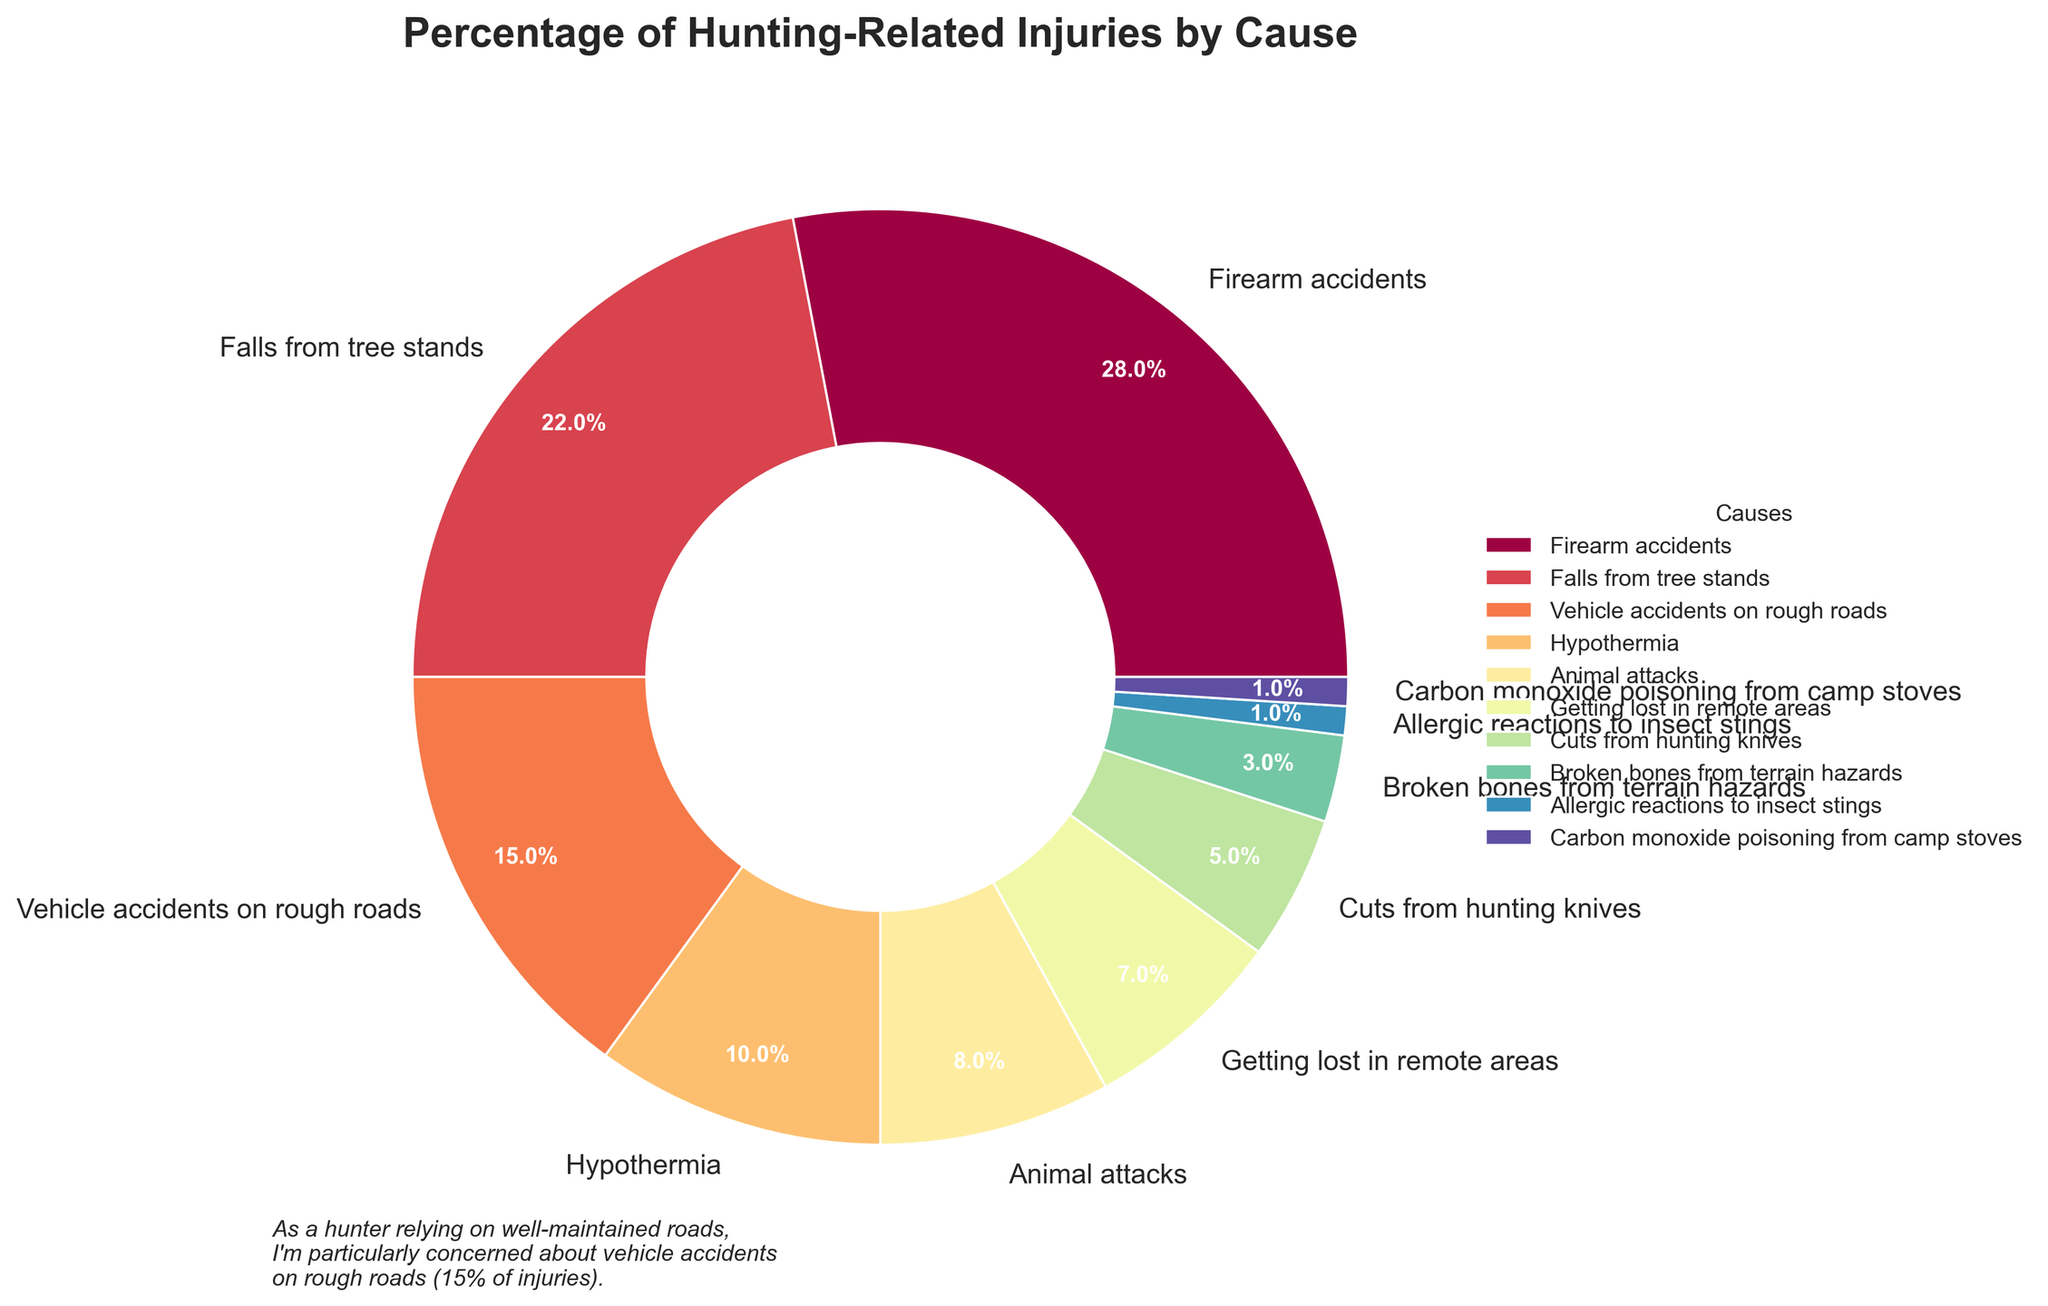What is the most common cause of hunting-related injuries? The largest wedge in the pie chart represents the most common cause. "Firearm accidents" occupy the largest segment at 28%.
Answer: Firearm accidents Which two causes combined account for 30% of hunting-related injuries? By examining the percentages, "Hypothermia" at 10% and "Animal attacks" at 8% combined are closest to 30%. However, falls from tree stands at 22% and cuts from hunting knives at 5% combined give exactly 27% and are the closest to 30%.
Answer: Falls from tree stands and cuts from hunting knives How much higher is the percentage of falls from tree stands compared to cuts from hunting knives? Identify the percentages for both causes. Falls from tree stands account for 22%, and cuts from hunting knives for 5%. The difference is 22% - 5%.
Answer: 17% What percentage of hunting-related injuries are due to factors other than firearm accidents, falls from tree stands, and vehicle accidents on rough roads? Subtract the three given percentages from 100%. Firearm accidents: 28%, falls from tree stands: 22%, vehicle accidents on rough roads: 15%. 100% - (28% + 22% + 15%) = 35%.
Answer: 35% Which cause of injuries is tied for the lowest percentage? Identify the smallest segments in the chart. Both "Allergic reactions to insect stings" and "Carbon monoxide poisoning from camp stoves" are 1%.
Answer: Allergic reactions to insect stings and Carbon monoxide poisoning from camp stoves What percentage of injuries are due to causes related to harsh weather conditions and the wilderness? Add the percentages for hypothermia and getting lost in remote areas, which are 10% and 7%, respectively. 10% + 7% = 17%.
Answer: 17% How does the percentage of injuries caused by animal attacks compare to those caused by getting lost in remote areas? The percentage for animal attacks is 8%, while getting lost accounts for 7%. Therefore, animal attacks are higher by 1%.
Answer: Animal attacks are 1% higher Which causes of injuries have percentages below 10%? Identify the values below 10% from the segments. The relevant causes are animal attacks (8%), getting lost in remote areas (7%), cuts from hunting knives (5%), broken bones from terrain hazards (3%), allergic reactions to insect stings (1%), and carbon monoxide poisoning from camp stoves (1%).
Answer: Animal attacks, Getting lost in remote areas, Cuts from hunting knives, Broken bones from terrain hazards, Allergic reactions to insect stings, Carbon monoxide poisoning from camp stoves What visual attribute can help quickly identify the percentage of injuries due to vehicle accidents on rough roads? Vehicle accidents on rough roads can be identified by the color used in the pie chart and its corresponding percentage label showing 15%.
Answer: Color and label What is the combined percentage of injuries caused by non-firearm accidents? Subtract the percentage of firearm accidents from 100%. Total = 100% - 28% = 72%.
Answer: 72% 